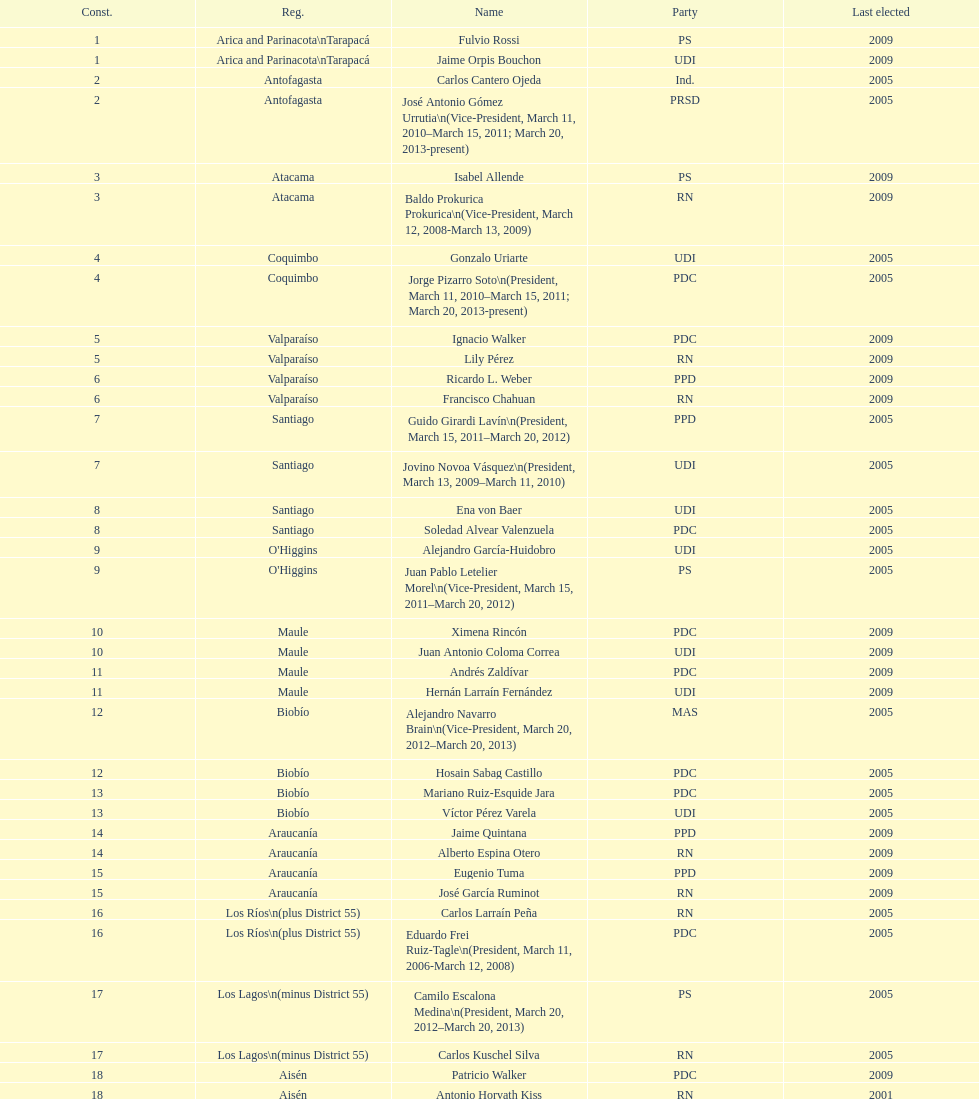What is the last region listed on the table? Magallanes. 